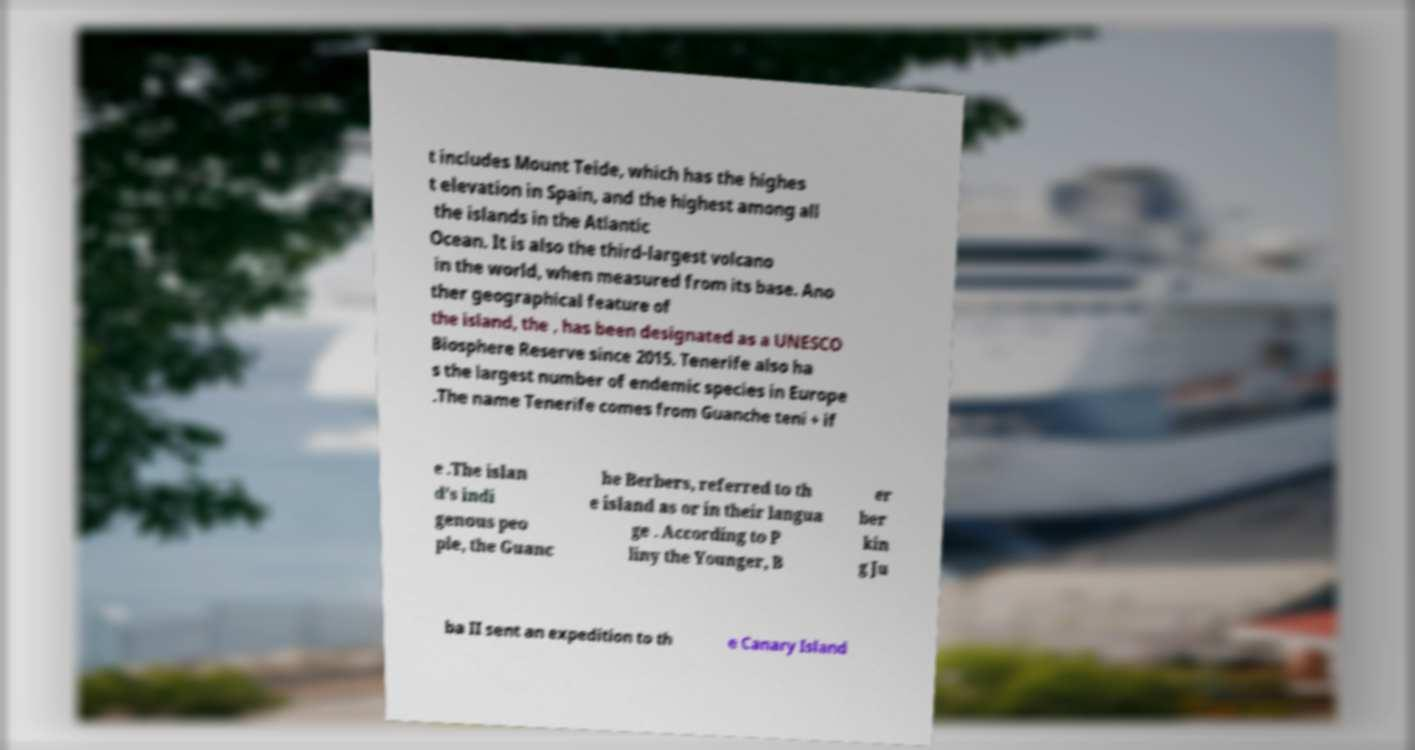For documentation purposes, I need the text within this image transcribed. Could you provide that? t includes Mount Teide, which has the highes t elevation in Spain, and the highest among all the islands in the Atlantic Ocean. It is also the third-largest volcano in the world, when measured from its base. Ano ther geographical feature of the island, the , has been designated as a UNESCO Biosphere Reserve since 2015. Tenerife also ha s the largest number of endemic species in Europe .The name Tenerife comes from Guanche teni + if e .The islan d's indi genous peo ple, the Guanc he Berbers, referred to th e island as or in their langua ge . According to P liny the Younger, B er ber kin g Ju ba II sent an expedition to th e Canary Island 